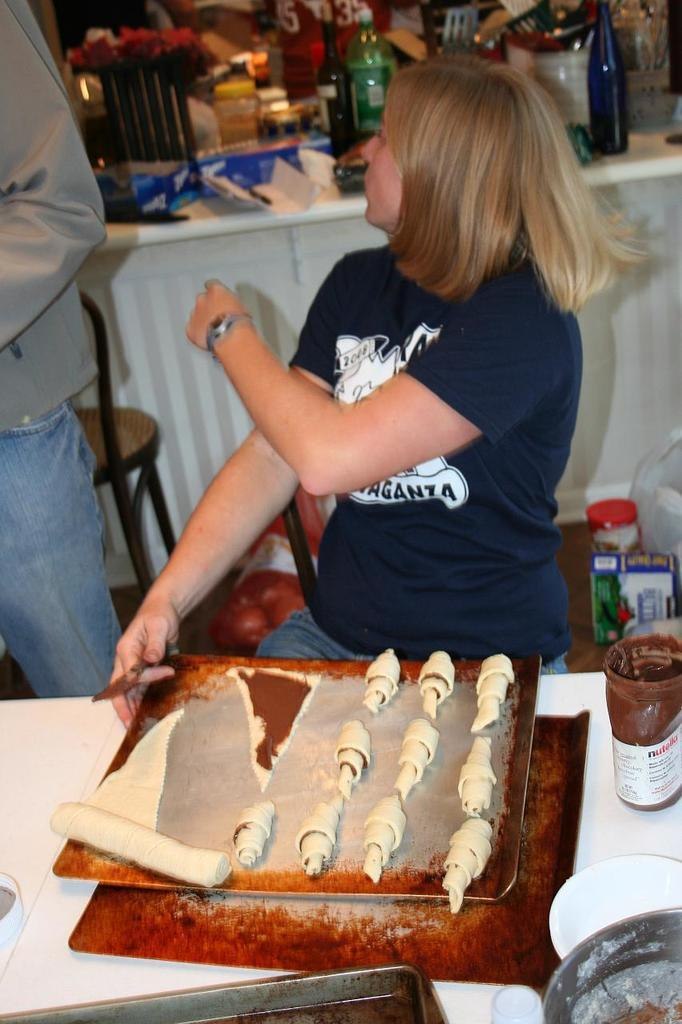How many people are in the image? There are two persons in the image. What is the woman doing in the image? The woman is sitting on a chair. What can be seen besides the persons in the image? There are bottles in the image. What is present on the table in the image? There are objects on a table in the image. What type of jar is the uncle holding in the image? There is no uncle or jar present in the image. What is the mass of the objects on the table in the image? The mass of the objects on the table cannot be determined from the image alone. 